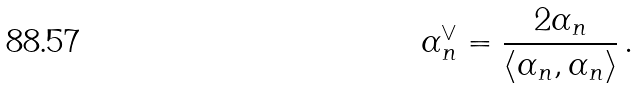Convert formula to latex. <formula><loc_0><loc_0><loc_500><loc_500>\alpha _ { n } ^ { \vee } = \frac { 2 \alpha _ { n } } { \langle \alpha _ { n } , \alpha _ { n } \rangle } \, .</formula> 